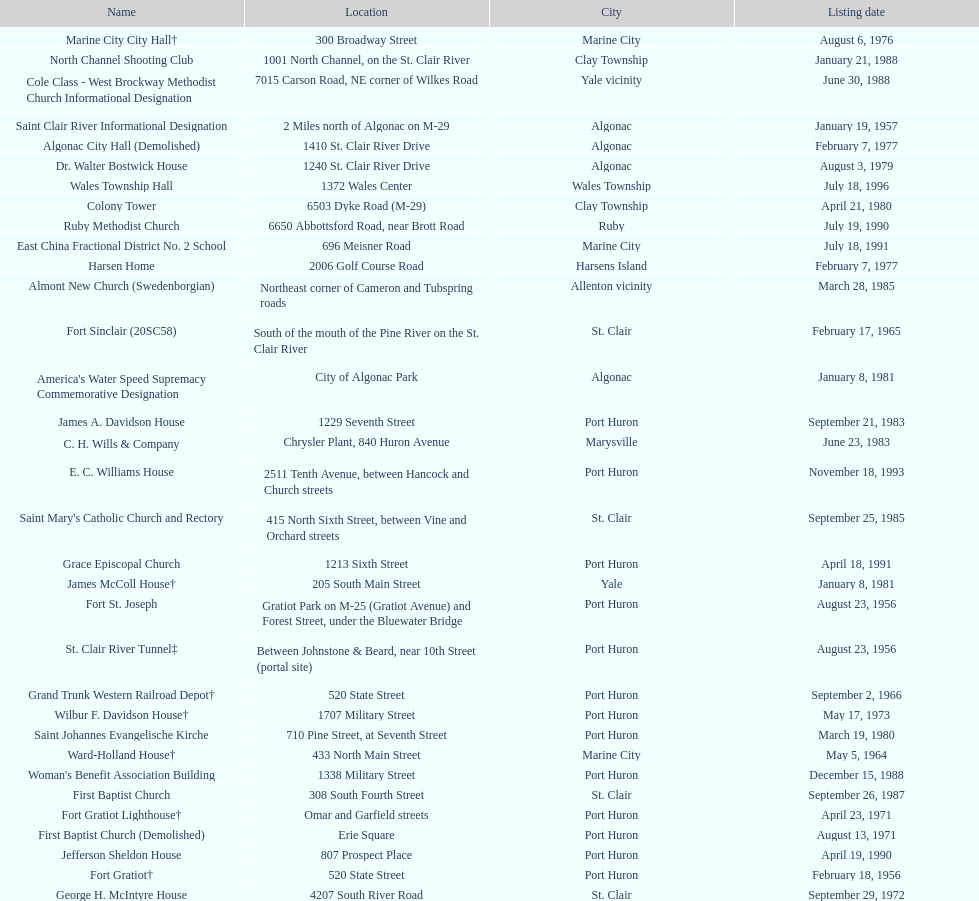How many names do not have images next to them? 41. Write the full table. {'header': ['Name', 'Location', 'City', 'Listing date'], 'rows': [['Marine City City Hall†', '300 Broadway Street', 'Marine City', 'August 6, 1976'], ['North Channel Shooting Club', '1001 North Channel, on the St. Clair River', 'Clay Township', 'January 21, 1988'], ['Cole Class - West Brockway Methodist Church Informational Designation', '7015 Carson Road, NE corner of Wilkes Road', 'Yale vicinity', 'June 30, 1988'], ['Saint Clair River Informational Designation', '2 Miles north of Algonac on M-29', 'Algonac', 'January 19, 1957'], ['Algonac City Hall (Demolished)', '1410 St. Clair River Drive', 'Algonac', 'February 7, 1977'], ['Dr. Walter Bostwick House', '1240 St. Clair River Drive', 'Algonac', 'August 3, 1979'], ['Wales Township Hall', '1372 Wales Center', 'Wales Township', 'July 18, 1996'], ['Colony Tower', '6503 Dyke Road (M-29)', 'Clay Township', 'April 21, 1980'], ['Ruby Methodist Church', '6650 Abbottsford Road, near Brott Road', 'Ruby', 'July 19, 1990'], ['East China Fractional District No. 2 School', '696 Meisner Road', 'Marine City', 'July 18, 1991'], ['Harsen Home', '2006 Golf Course Road', 'Harsens Island', 'February 7, 1977'], ['Almont New Church (Swedenborgian)', 'Northeast corner of Cameron and Tubspring roads', 'Allenton vicinity', 'March 28, 1985'], ['Fort Sinclair (20SC58)', 'South of the mouth of the Pine River on the St. Clair River', 'St. Clair', 'February 17, 1965'], ["America's Water Speed Supremacy Commemorative Designation", 'City of Algonac Park', 'Algonac', 'January 8, 1981'], ['James A. Davidson House', '1229 Seventh Street', 'Port Huron', 'September 21, 1983'], ['C. H. Wills & Company', 'Chrysler Plant, 840 Huron Avenue', 'Marysville', 'June 23, 1983'], ['E. C. Williams House', '2511 Tenth Avenue, between Hancock and Church streets', 'Port Huron', 'November 18, 1993'], ["Saint Mary's Catholic Church and Rectory", '415 North Sixth Street, between Vine and Orchard streets', 'St. Clair', 'September 25, 1985'], ['Grace Episcopal Church', '1213 Sixth Street', 'Port Huron', 'April 18, 1991'], ['James McColl House†', '205 South Main Street', 'Yale', 'January 8, 1981'], ['Fort St. Joseph', 'Gratiot Park on M-25 (Gratiot Avenue) and Forest Street, under the Bluewater Bridge', 'Port Huron', 'August 23, 1956'], ['St. Clair River Tunnel‡', 'Between Johnstone & Beard, near 10th Street (portal site)', 'Port Huron', 'August 23, 1956'], ['Grand Trunk Western Railroad Depot†', '520 State Street', 'Port Huron', 'September 2, 1966'], ['Wilbur F. Davidson House†', '1707 Military Street', 'Port Huron', 'May 17, 1973'], ['Saint Johannes Evangelische Kirche', '710 Pine Street, at Seventh Street', 'Port Huron', 'March 19, 1980'], ['Ward-Holland House†', '433 North Main Street', 'Marine City', 'May 5, 1964'], ["Woman's Benefit Association Building", '1338 Military Street', 'Port Huron', 'December 15, 1988'], ['First Baptist Church', '308 South Fourth Street', 'St. Clair', 'September 26, 1987'], ['Fort Gratiot Lighthouse†', 'Omar and Garfield streets', 'Port Huron', 'April 23, 1971'], ['First Baptist Church (Demolished)', 'Erie Square', 'Port Huron', 'August 13, 1971'], ['Jefferson Sheldon House', '807 Prospect Place', 'Port Huron', 'April 19, 1990'], ['Fort Gratiot†', '520 State Street', 'Port Huron', 'February 18, 1956'], ['George H. McIntyre House', '4207 South River Road', 'St. Clair', 'September 29, 1972'], ['Gratiot Park United Methodist Church', '2503 Cherry Street', 'Port Huron', 'March 10, 1988'], ['Graziadei-Casello Building', '307 Huron Avenue', 'Port Huron', 'November 16, 1995'], ['Catholic Pointe', '618 South Water Street, SE corner of Bridge Street', 'Marine City', 'August 12, 1977'], ['Harrington Hotel†', '1026 Military, between Pine and Wall Streets', 'Port Huron', 'November 16, 1981'], ['Saint Clair Inn†', '500 Riverside', 'St. Clair', 'October 20, 1994'], ['Port Huron High School', '323 Erie Street', 'Port Huron', 'December 15, 1988'], ['Lightship No. 103‡', 'Pine Grove Park', 'Port Huron', 'May 17, 1973'], ['Trinity Evangelical Lutheran Church', '1517 Tenth Street', 'Port Huron', 'August 29, 1996'], ["Saint Andrew's Episcopal Church", '1507 St. Clair River Drive', 'Algonac', 'January 16, 1990'], ['Newport Academy', '405 South Main Street', 'Marine City', 'June 15, 1979'], ['Congregational Church', '300 Adams St', 'St. Clair', 'August 3, 1979'], ['Ladies of the Maccabees Building†', '901 Huron Avenue', 'Port Huron', 'November 16, 1982']]} 